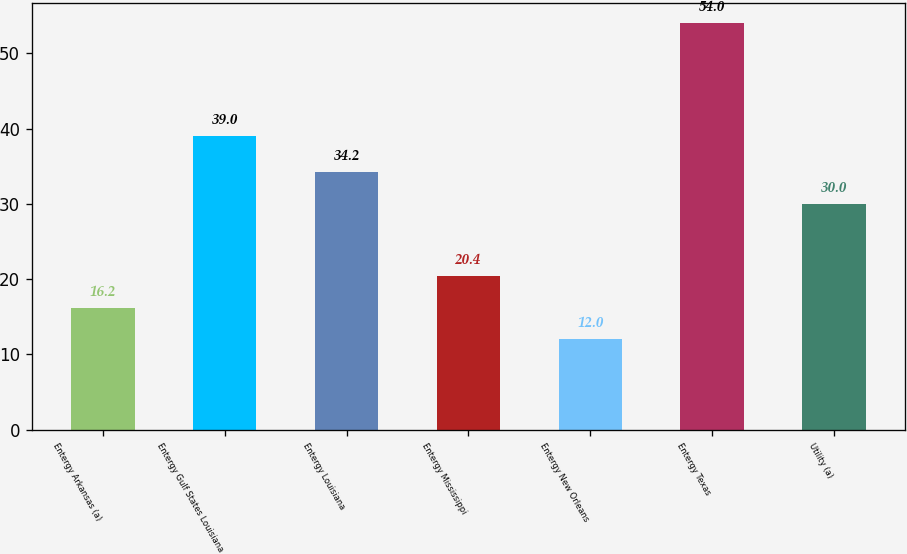<chart> <loc_0><loc_0><loc_500><loc_500><bar_chart><fcel>Entergy Arkansas (a)<fcel>Entergy Gulf States Louisiana<fcel>Entergy Louisiana<fcel>Entergy Mississippi<fcel>Entergy New Orleans<fcel>Entergy Texas<fcel>Utility (a)<nl><fcel>16.2<fcel>39<fcel>34.2<fcel>20.4<fcel>12<fcel>54<fcel>30<nl></chart> 